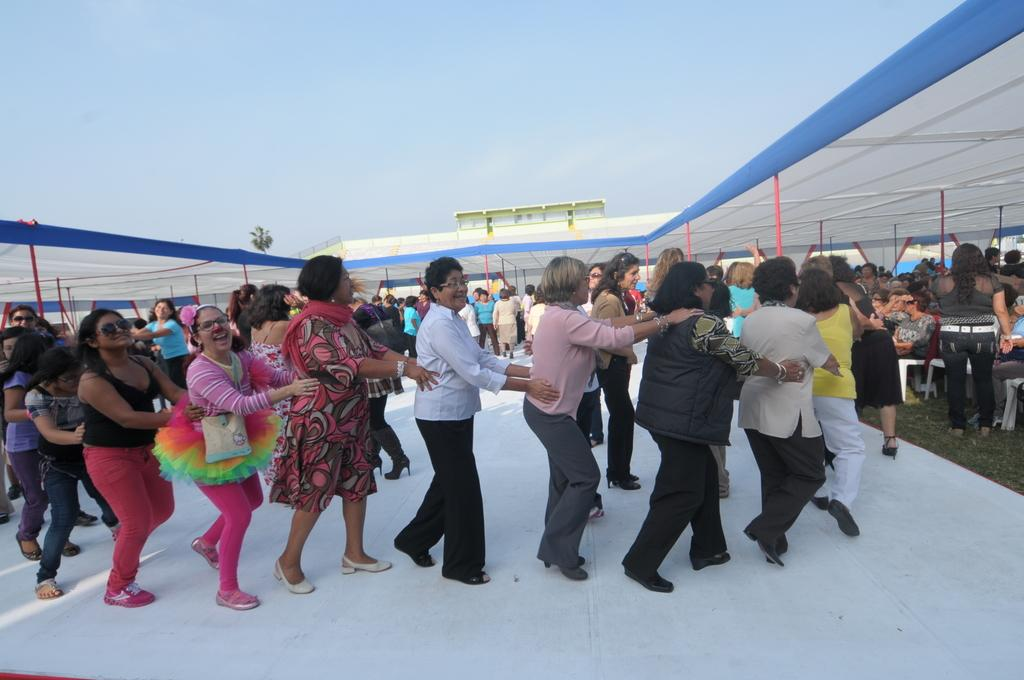What can be seen under the tents in the image? There are people under the tents in the image. What activity are the people engaged in on the white surface? The people are playing on the white surface in the image. How many sheep can be seen singing a song in the image? There are no sheep or singing in the image; it features people under tents and playing on a white surface. 